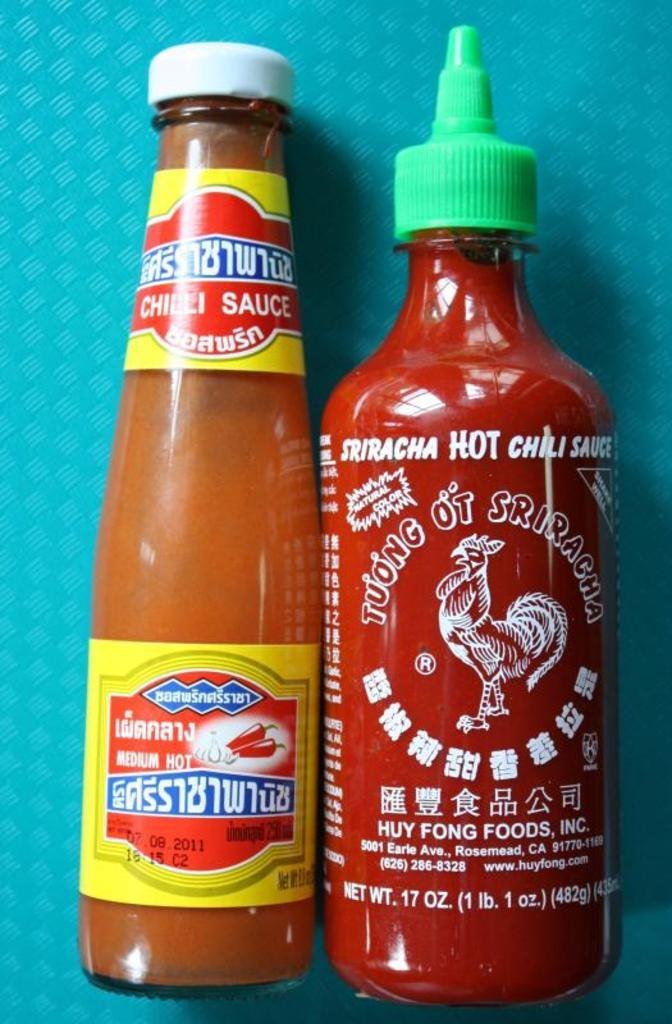<image>
Create a compact narrative representing the image presented. Bottle of chili sauce next to bottle of Sriracha hot chili sauce 